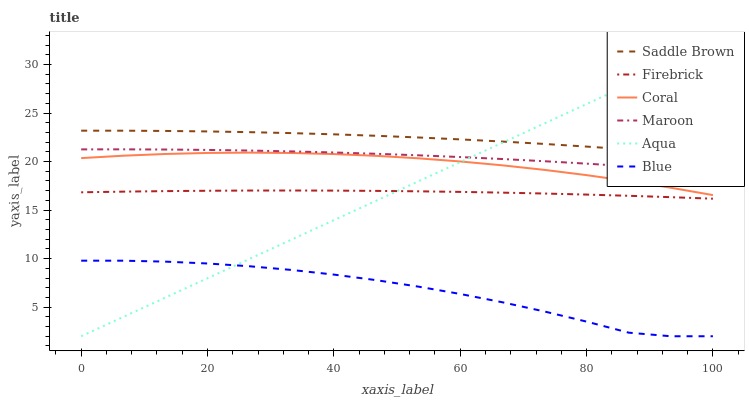Does Coral have the minimum area under the curve?
Answer yes or no. No. Does Coral have the maximum area under the curve?
Answer yes or no. No. Is Coral the smoothest?
Answer yes or no. No. Is Coral the roughest?
Answer yes or no. No. Does Coral have the lowest value?
Answer yes or no. No. Does Coral have the highest value?
Answer yes or no. No. Is Firebrick less than Maroon?
Answer yes or no. Yes. Is Firebrick greater than Blue?
Answer yes or no. Yes. Does Firebrick intersect Maroon?
Answer yes or no. No. 